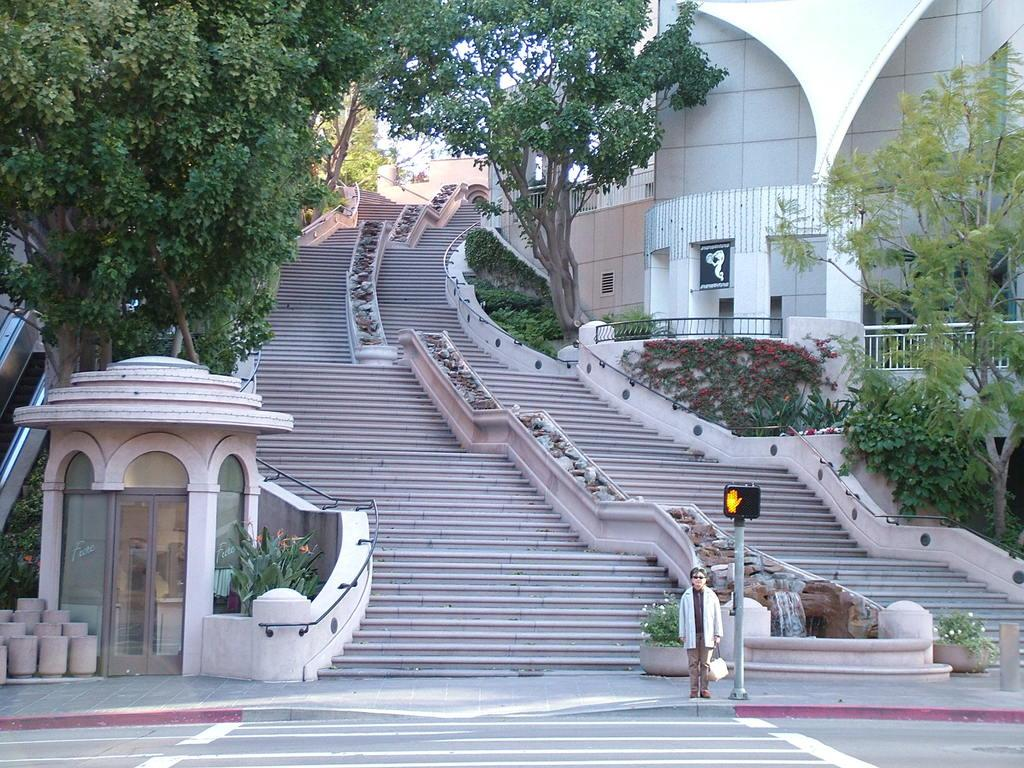What is the person in the image doing? The person is standing and holding a bag. What can be seen beside the person? There is a board on a pole beside the person. What architectural feature is visible in the image? Steps are visible in the image. What type of vegetation is present in the image? Plants and trees are present in the image. What is the background of the image? There is a wall in the image, and the sky is visible. How does the kitten contribute to the border in the image? There is no kitten present in the image, and therefore it cannot contribute to any borders. 